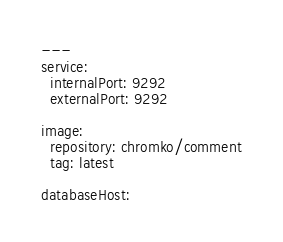<code> <loc_0><loc_0><loc_500><loc_500><_YAML_>---
service:
  internalPort: 9292
  externalPort: 9292

image:
  repository: chromko/comment
  tag: latest

databaseHost:
</code> 